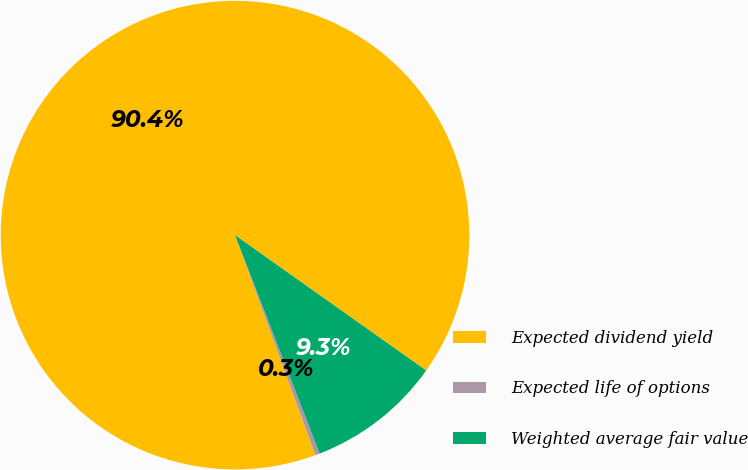Convert chart. <chart><loc_0><loc_0><loc_500><loc_500><pie_chart><fcel>Expected dividend yield<fcel>Expected life of options<fcel>Weighted average fair value<nl><fcel>90.38%<fcel>0.31%<fcel>9.31%<nl></chart> 